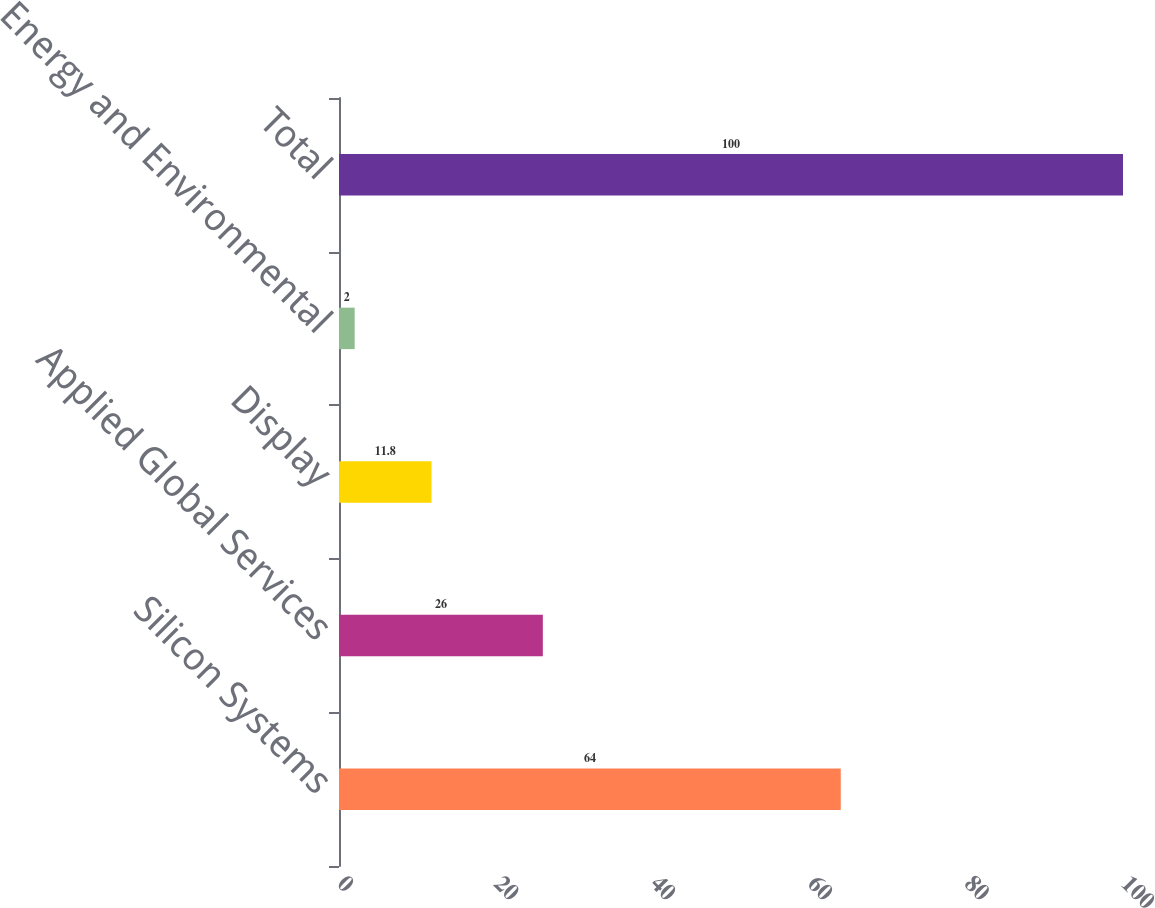Convert chart. <chart><loc_0><loc_0><loc_500><loc_500><bar_chart><fcel>Silicon Systems<fcel>Applied Global Services<fcel>Display<fcel>Energy and Environmental<fcel>Total<nl><fcel>64<fcel>26<fcel>11.8<fcel>2<fcel>100<nl></chart> 